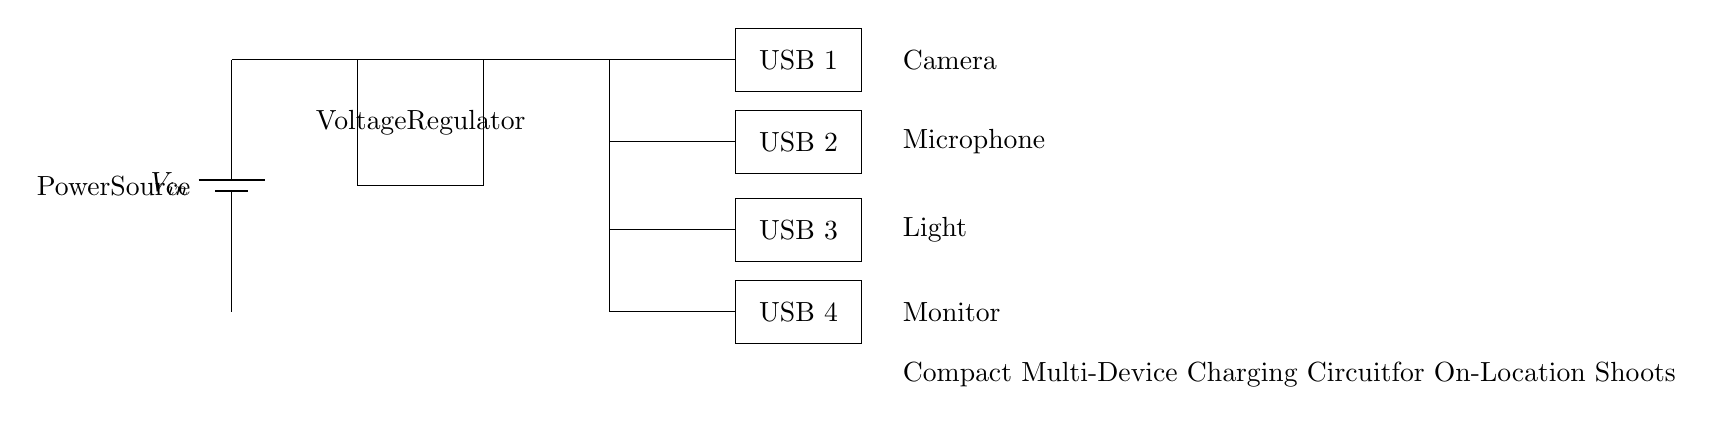What is the main power source in the circuit? The main power source is a battery, which is indicated by the battery symbol labeled as V_in.
Answer: Battery How many USB charging ports are present? There are four USB charging ports in the circuit, each indicated by a rectangle labeled as USB 1, USB 2, USB 3, and USB 4.
Answer: Four What component regulates the voltage in this circuit? The component that regulates the voltage is labeled as Voltage Regulator, shown as a rectangle in the circuit diagram.
Answer: Voltage Regulator Which devices are connected to this charging circuit? The devices connected to the charging circuit are a camera, microphone, light, and monitor, which are shown with their respective labels near the USB ports.
Answer: Camera, Microphone, Light, Monitor What is the configuration of the USB ports in the circuit? The USB ports are situated in a parallel configuration, where each port connects from the output of the voltage regulator to respective devices.
Answer: Parallel At what location is the voltage regulator situated in the circuit? The voltage regulator is positioned between the power source and the USB ports, receiving voltage from the power source and supplying it to the ports.
Answer: Between power source and USB ports What is the purpose of the voltage regulator in this circuit? The purpose of the voltage regulator is to ensure that the voltage supplied to the USB ports remains within a specific range suitable for charging devices, thereby providing stable charging.
Answer: Stable charging 